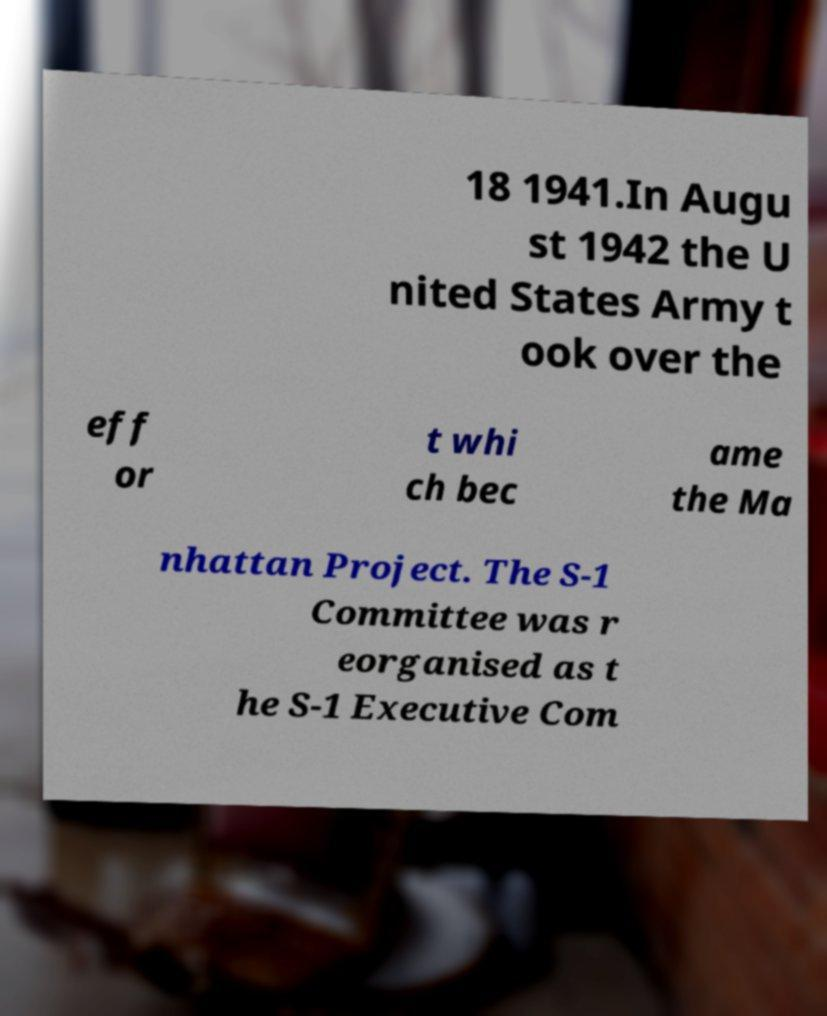Could you extract and type out the text from this image? 18 1941.In Augu st 1942 the U nited States Army t ook over the eff or t whi ch bec ame the Ma nhattan Project. The S-1 Committee was r eorganised as t he S-1 Executive Com 